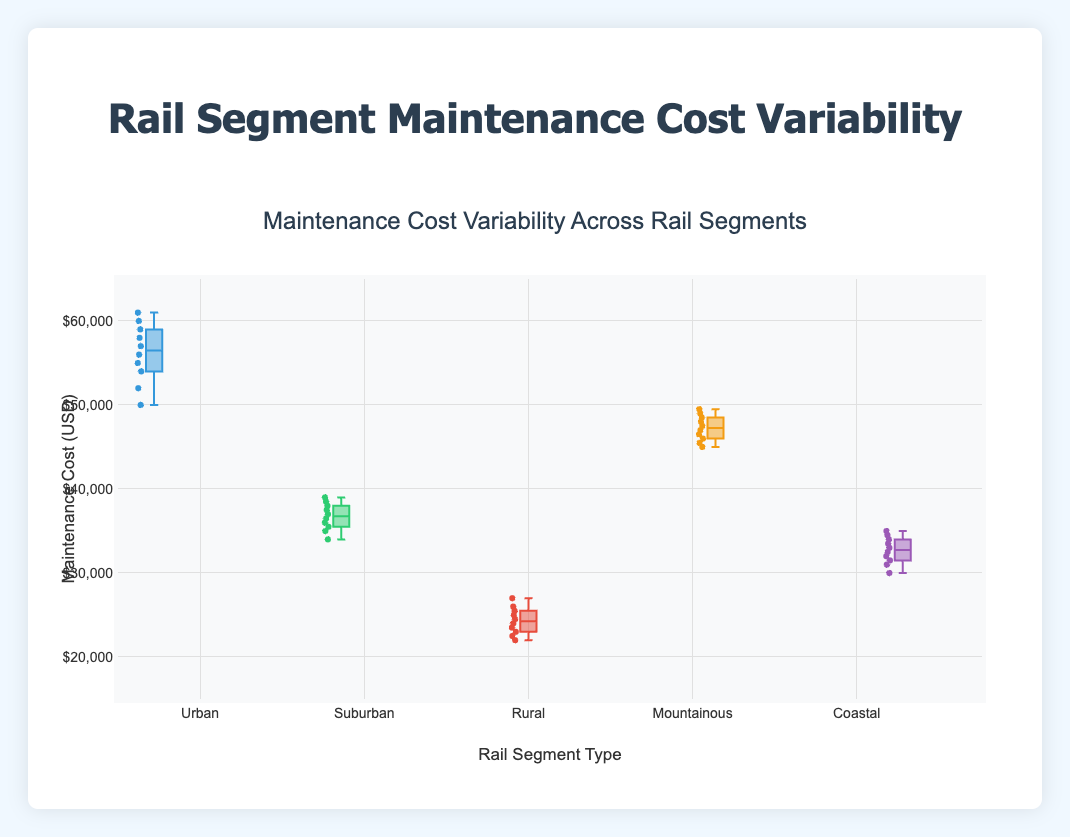What is the median maintenance cost for Urban segments? The median is the middle value in a dataset when it's ordered from least to greatest. For the Urban segment, the sorted costs are (50000, 52000, 54000, 55000, 56000, 57000, 58000, 59000, 60000, 61000). The median is the average of the 5th and 6th values, which are 56000 and 57000. So, the median is (56000 + 57000)/2 = 56500.
Answer: 56500 How many segments have a median maintenance cost above $40000? We will identify segments with medians above $40000 by comparing their median values: Urban (56500), Suburban (37000), Rural (24000), Mountainous (47000), and Coastal (32500). Only Urban and Mountainous have median costs above $40000.
Answer: 2 Which segment has the highest variability in maintenance costs? Variability in maintenance costs can be visually assessed from the box plot by looking at the spread of the whiskers and the size of the interquartile range. The Urban segment has the largest spread and interquartile range, indicating the highest variability.
Answer: Urban What is the range of maintenance costs in the Coastal segment? The range in a dataset is calculated by subtracting the smallest value from the largest value. For the Coastal segment, the range is 35000 (max) - 30000 (min) = 5000.
Answer: 5000 Which segment has the lowest median maintenance cost? By visually comparing the median lines in each box, the Rural segment has the lowest median maintenance cost.
Answer: Rural How does the median maintenance cost of the Mountainous segment compare to the Suburban segment? The median maintenance cost for the Mountainous segment is 47000, while for the Suburban segment, it is 37000. The Mountainous segment's median is higher by 10000.
Answer: Mountainous is higher by 10000 Are there any outliers in the Rural segment? In a box plot, outliers are typically shown as individual points outside the whiskers. For the Rural segment, there are no individual points outside the whiskers, indicating no outliers.
Answer: No What's the difference between the highest maintenance costs in Urban and Coastal segments? The highest maintenance cost in the Urban segment is 61000, and in the Coastal segment, it is 35000. The difference is 61000 - 35000 = 26000.
Answer: 26000 Which segment shows the smallest interquartile range (IQR) for maintenance costs? The interquartile range is the difference between the upper (Q3) and lower (Q1) quartiles. By visual assessment, the Coastal segment has the smallest IQR, indicating less variability within the middle 50% of its data.
Answer: Coastal 